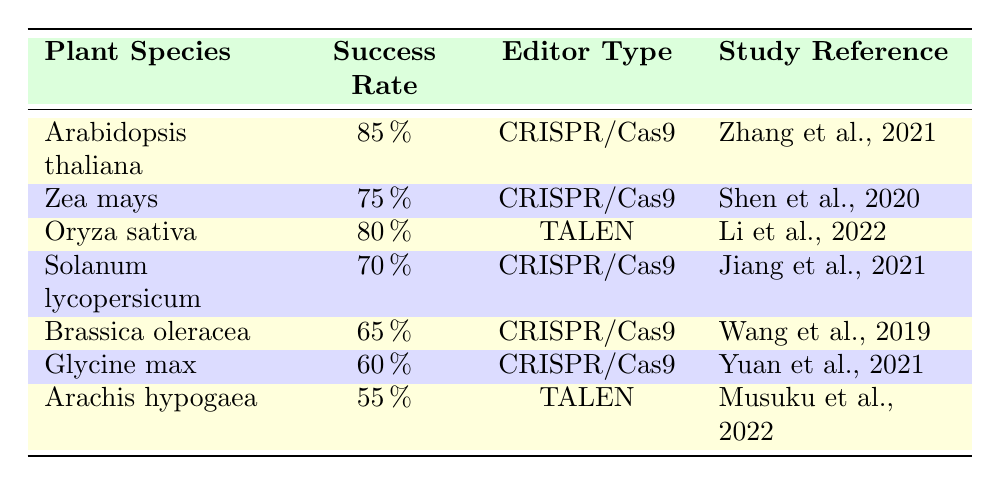What is the success rate for Arabidopsis thaliana? The table lists Arabidopsis thaliana with a success rate of 85%, found in the first row under the "Success Rate" column.
Answer: 85% Which editing type has the highest success rate among these plants? Looking at the "Success Rate" column, Arabidopsis thaliana has the highest success rate of 85%, using CRISPR/Cas9. No other plant matches or exceeds this value.
Answer: CRISPR/Cas9 What is the average success rate of plants edited using CRISPR/Cas9? The success rates for CRISPR/Cas9 from the table are 85%, 75%, 70%, 65%, and 60%. Summing these gives 85 + 75 + 70 + 65 + 60 = 355. There are 5 data points, so the average success rate is 355/5 = 71%.
Answer: 71% Is the success rate for Glycine max greater than the success rate for Arachis hypogaea? Glycine max has a success rate of 60%, while Arachis hypogaea has a success rate of 55%. Since 60 is greater than 55, the answer is yes.
Answer: Yes Which plant species has the lowest success rate and what is that rate? Reviewing the table, Arachis hypogaea has the lowest success rate of 55%, as it is listed last in the table under the "Success Rate" column.
Answer: Arachis hypogaea, 55% How many plant species are listed with a success rate above 70%? From the table, Arabidopsis thaliana (85%), Zea mays (75%), and Oryza sativa (80%) have success rates above 70%. Counting these, there are three species.
Answer: 3 Does the table show any plant that has a success rate of 65% or higher using TALEN editing? Oryza sativa at 80% and Arachis hypogaea at 55% are the two plants using TALEN. Since Oryza sativa exceeds 65% and Arachis hypogaea does not, the answer is yes.
Answer: Yes Between the plants listed, how many use CRISPR/Cas9 editing? By analyzing the table, Arabidopsis thaliana, Zea mays, Solanum lycopersicum, Brassica oleracea, and Glycine max are all using CRISPR/Cas9 editing. Counting these gives a total of five.
Answer: 5 